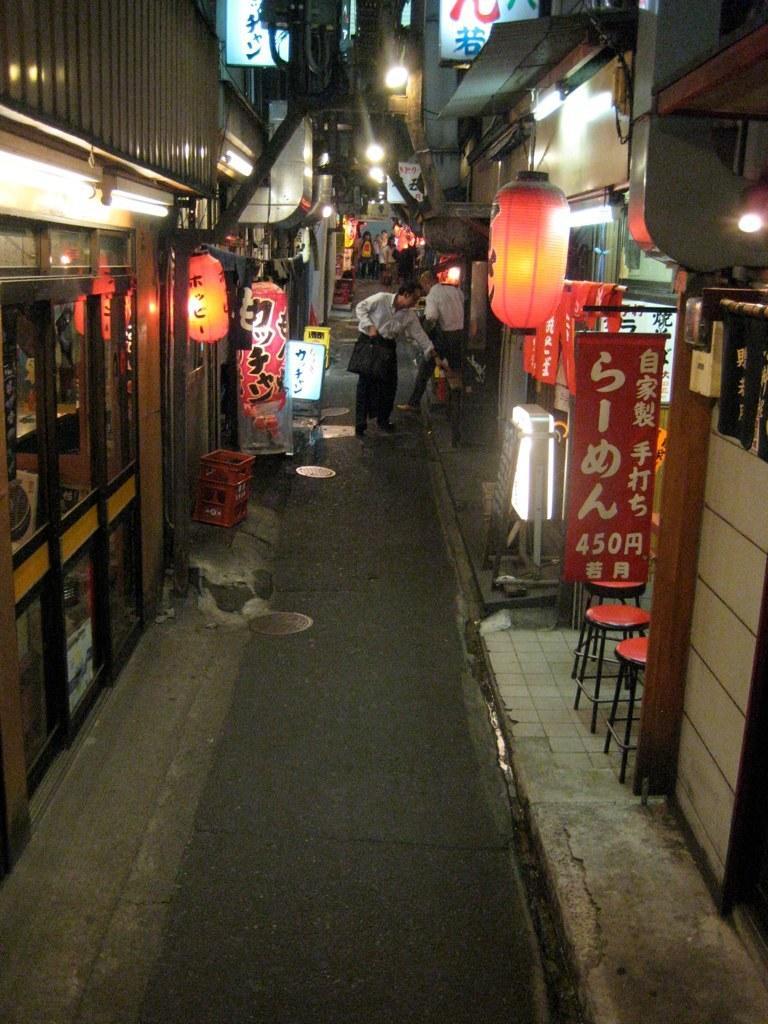Describe this image in one or two sentences. In this image, we can see people on the road and in the background, there are buildings, lights, poles, some boxes, chairs, banners and there are wires. 